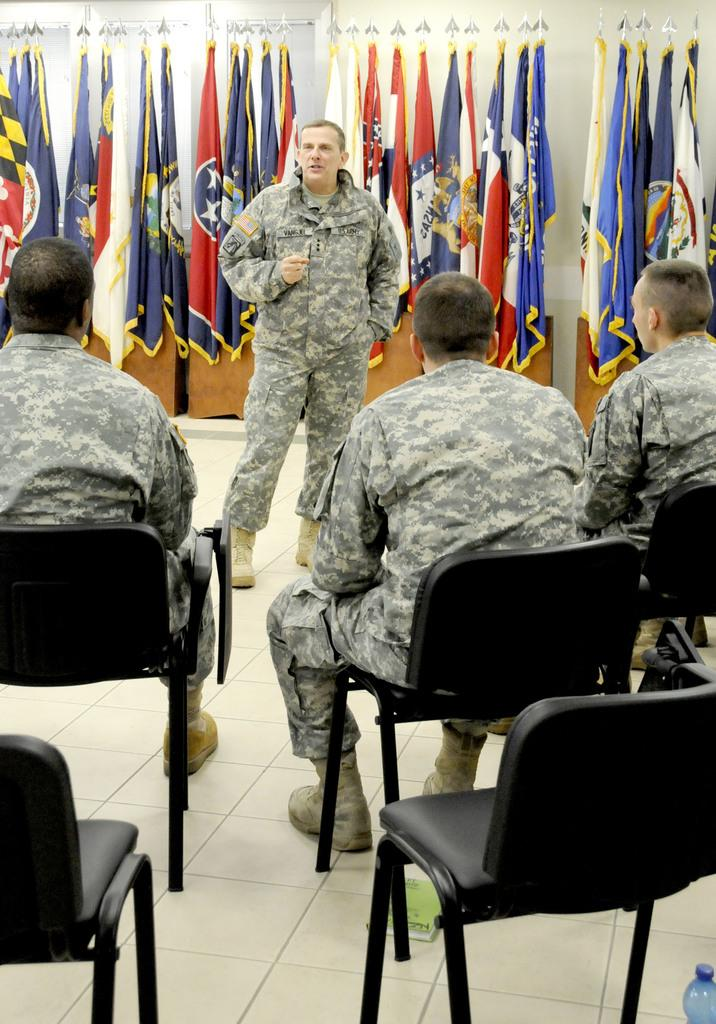How many people are sitting in the image? There are three people sitting on chairs in the image. What is the position of the person in front of the seated people? There is a person standing in front of the seated people. What can be seen behind the standing person? There are flags visible behind the standing person. What color is the balloon held by the parent in the image? There is no balloon or parent present in the image. How many baskets are visible on the chairs in the image? There are no baskets visible on the chairs in the image. 